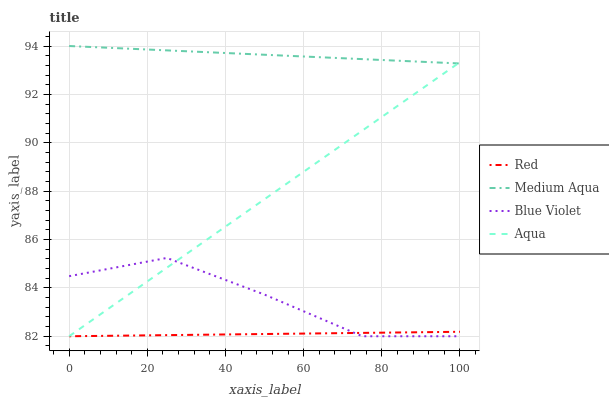Does Red have the minimum area under the curve?
Answer yes or no. Yes. Does Medium Aqua have the maximum area under the curve?
Answer yes or no. Yes. Does Blue Violet have the minimum area under the curve?
Answer yes or no. No. Does Blue Violet have the maximum area under the curve?
Answer yes or no. No. Is Aqua the smoothest?
Answer yes or no. Yes. Is Blue Violet the roughest?
Answer yes or no. Yes. Is Medium Aqua the smoothest?
Answer yes or no. No. Is Medium Aqua the roughest?
Answer yes or no. No. Does Aqua have the lowest value?
Answer yes or no. Yes. Does Medium Aqua have the lowest value?
Answer yes or no. No. Does Medium Aqua have the highest value?
Answer yes or no. Yes. Does Blue Violet have the highest value?
Answer yes or no. No. Is Red less than Medium Aqua?
Answer yes or no. Yes. Is Medium Aqua greater than Red?
Answer yes or no. Yes. Does Medium Aqua intersect Aqua?
Answer yes or no. Yes. Is Medium Aqua less than Aqua?
Answer yes or no. No. Is Medium Aqua greater than Aqua?
Answer yes or no. No. Does Red intersect Medium Aqua?
Answer yes or no. No. 